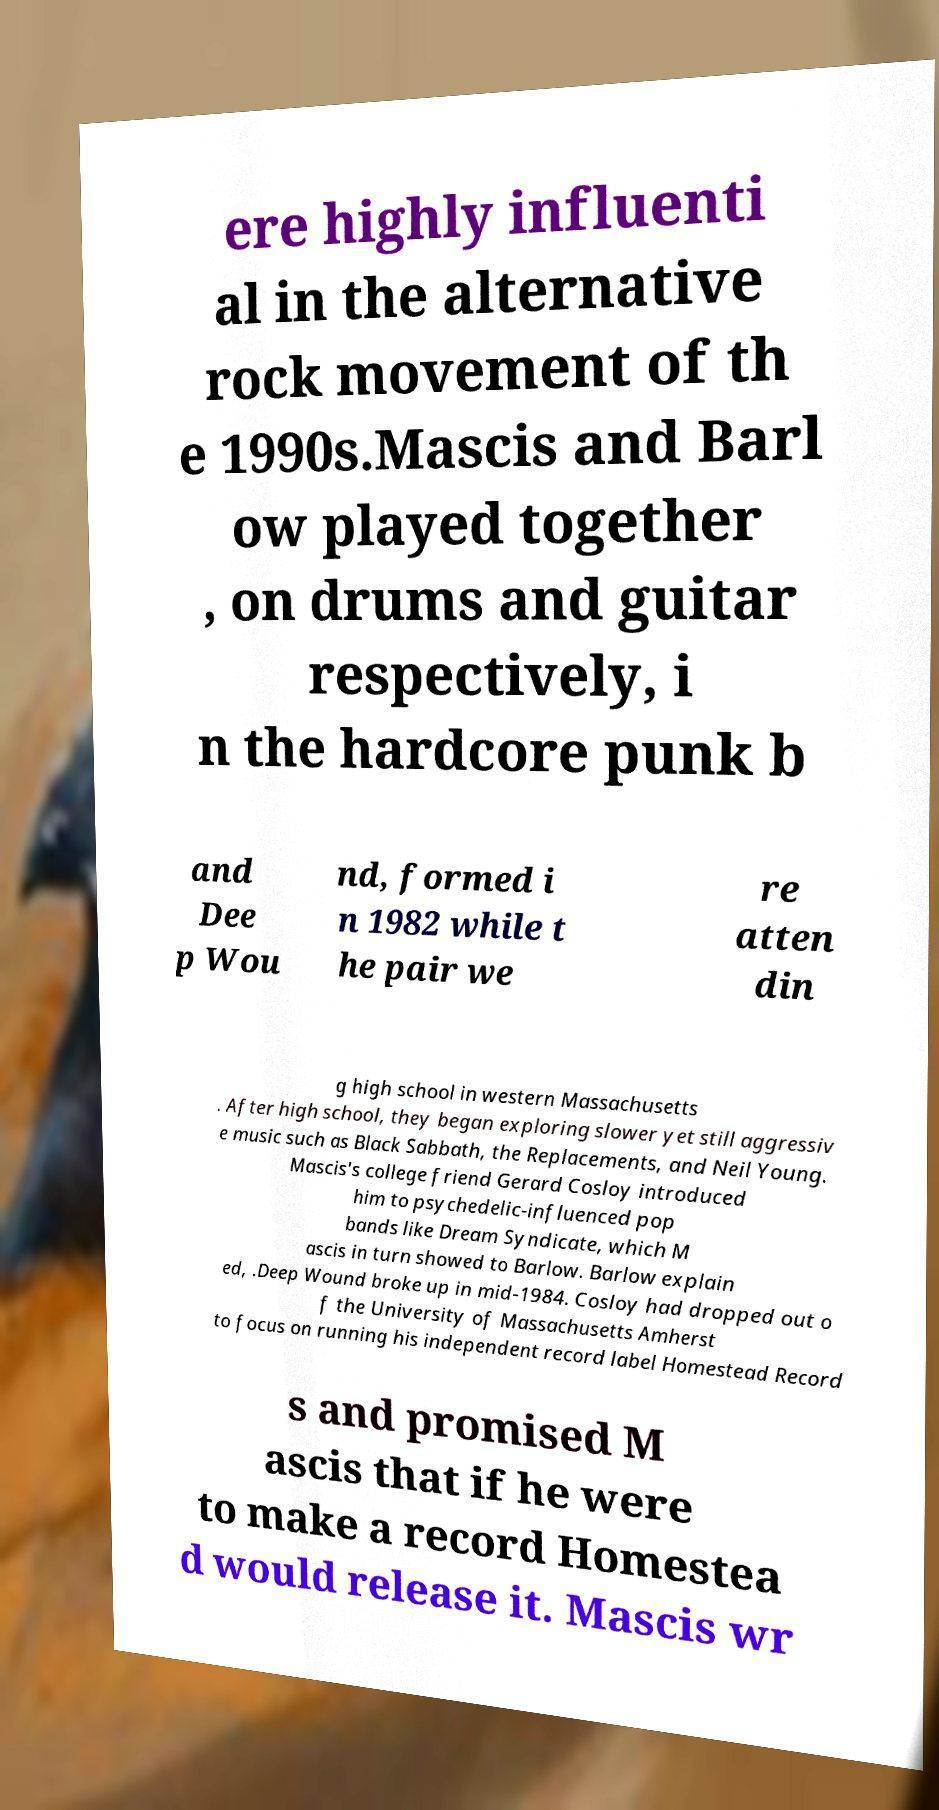What messages or text are displayed in this image? I need them in a readable, typed format. ere highly influenti al in the alternative rock movement of th e 1990s.Mascis and Barl ow played together , on drums and guitar respectively, i n the hardcore punk b and Dee p Wou nd, formed i n 1982 while t he pair we re atten din g high school in western Massachusetts . After high school, they began exploring slower yet still aggressiv e music such as Black Sabbath, the Replacements, and Neil Young. Mascis's college friend Gerard Cosloy introduced him to psychedelic-influenced pop bands like Dream Syndicate, which M ascis in turn showed to Barlow. Barlow explain ed, .Deep Wound broke up in mid-1984. Cosloy had dropped out o f the University of Massachusetts Amherst to focus on running his independent record label Homestead Record s and promised M ascis that if he were to make a record Homestea d would release it. Mascis wr 